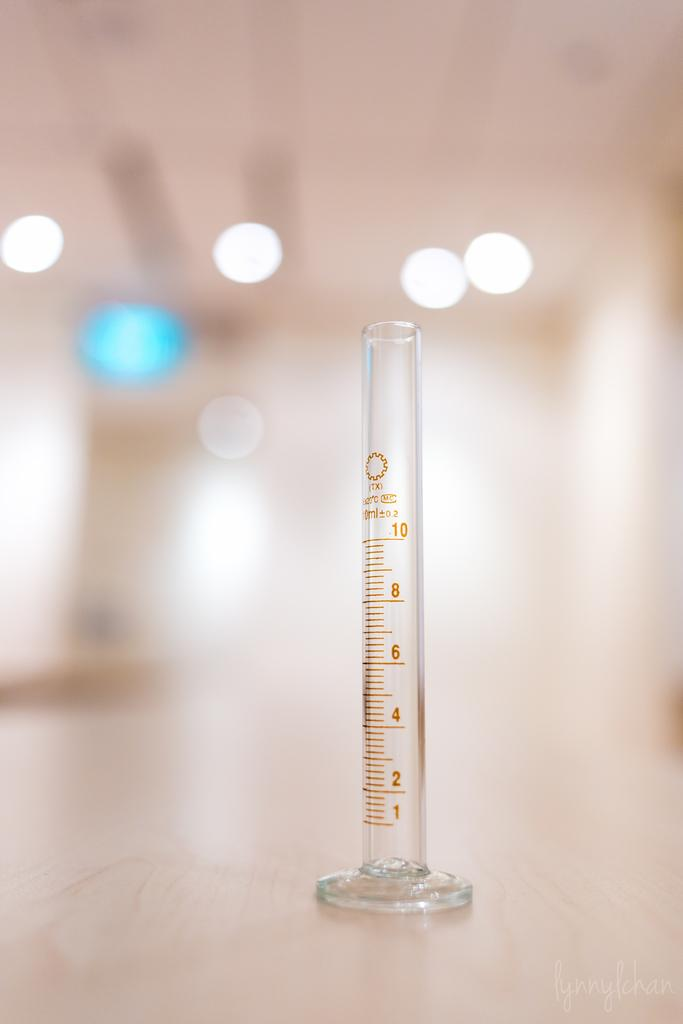<image>
Write a terse but informative summary of the picture. a tube that has the number ten at the top 